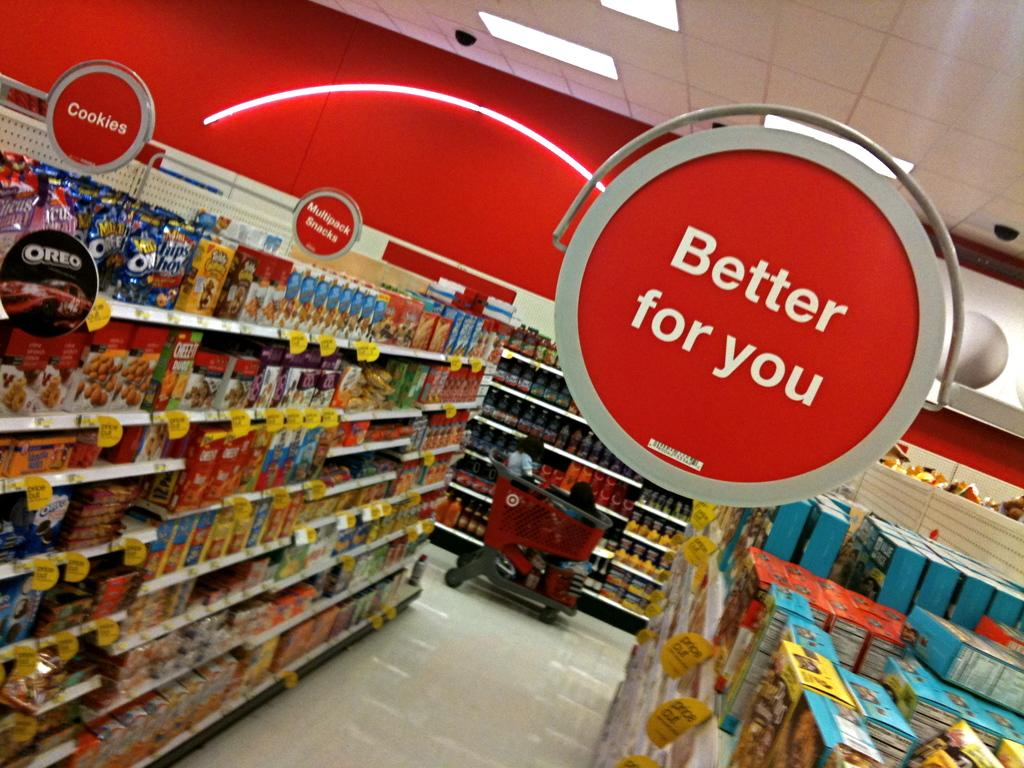<image>
Present a compact description of the photo's key features. Store aisle with a sign that says Better For You. 